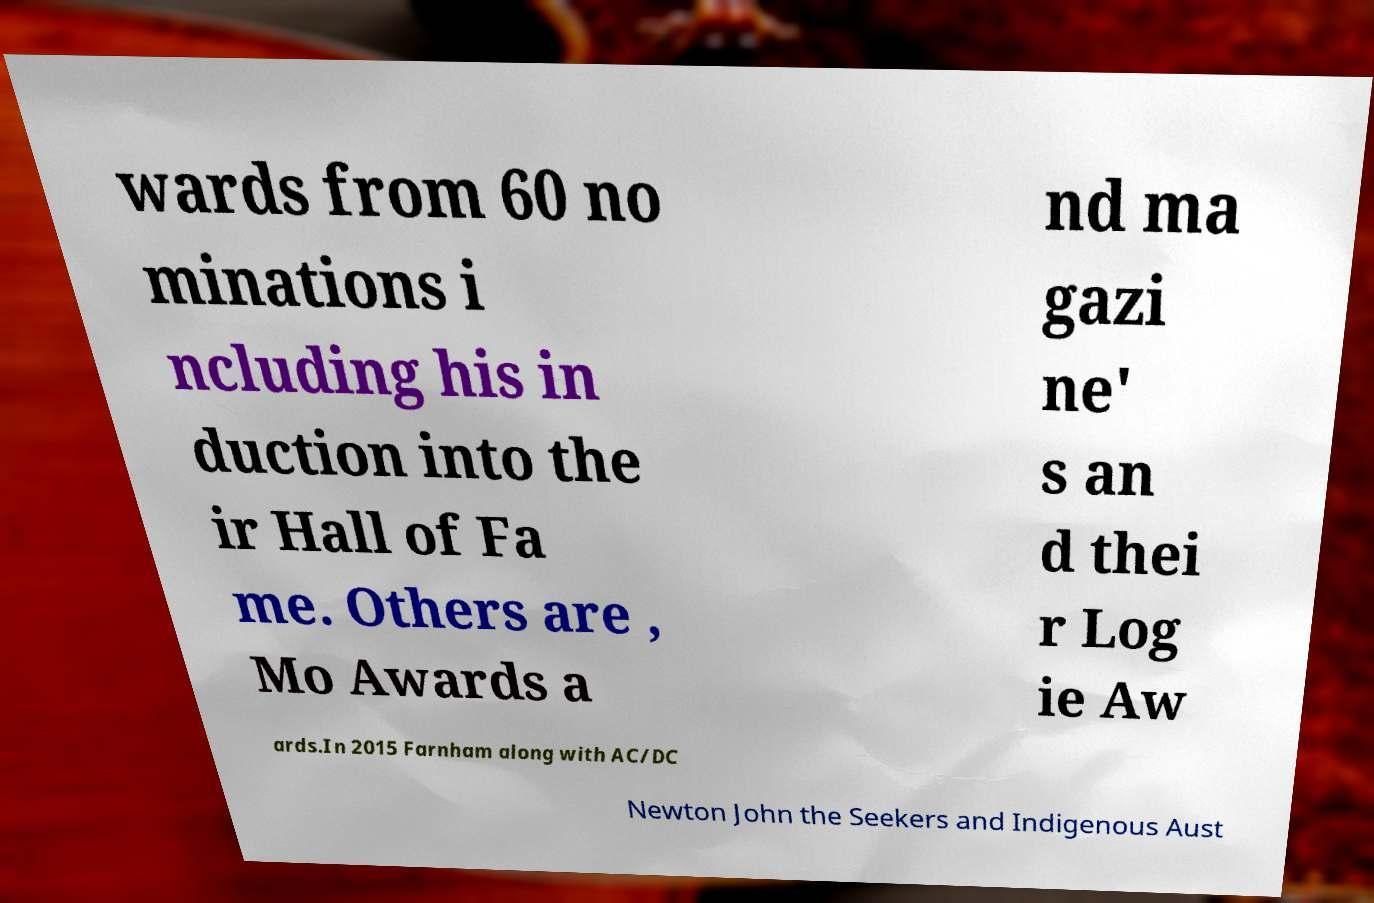What messages or text are displayed in this image? I need them in a readable, typed format. wards from 60 no minations i ncluding his in duction into the ir Hall of Fa me. Others are , Mo Awards a nd ma gazi ne' s an d thei r Log ie Aw ards.In 2015 Farnham along with AC/DC Newton John the Seekers and Indigenous Aust 